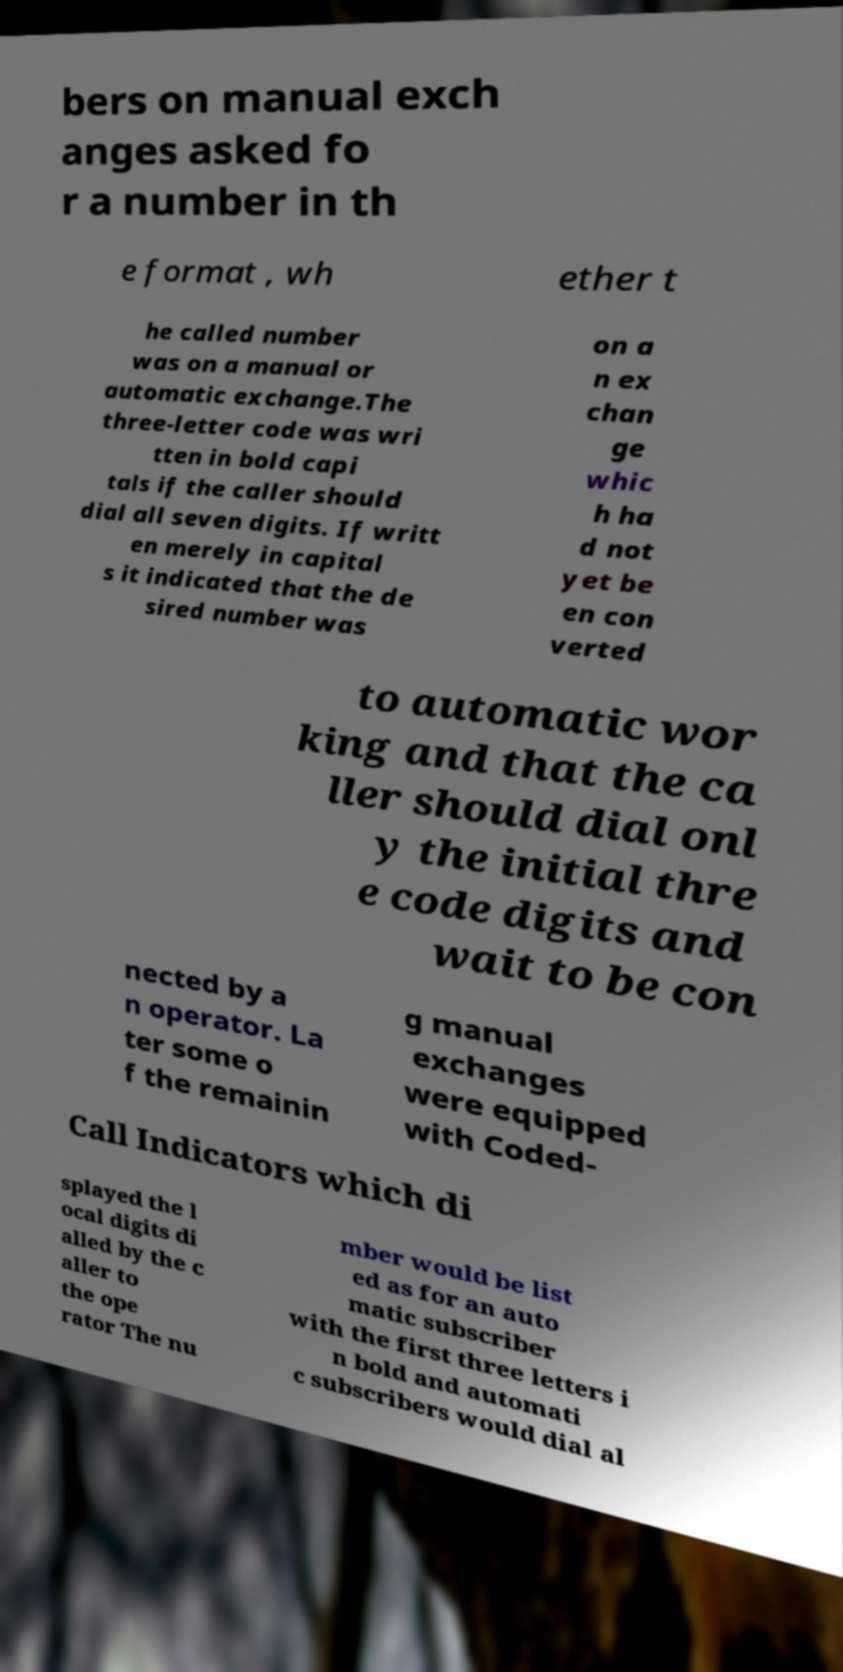Can you read and provide the text displayed in the image?This photo seems to have some interesting text. Can you extract and type it out for me? bers on manual exch anges asked fo r a number in th e format , wh ether t he called number was on a manual or automatic exchange.The three-letter code was wri tten in bold capi tals if the caller should dial all seven digits. If writt en merely in capital s it indicated that the de sired number was on a n ex chan ge whic h ha d not yet be en con verted to automatic wor king and that the ca ller should dial onl y the initial thre e code digits and wait to be con nected by a n operator. La ter some o f the remainin g manual exchanges were equipped with Coded- Call Indicators which di splayed the l ocal digits di alled by the c aller to the ope rator The nu mber would be list ed as for an auto matic subscriber with the first three letters i n bold and automati c subscribers would dial al 